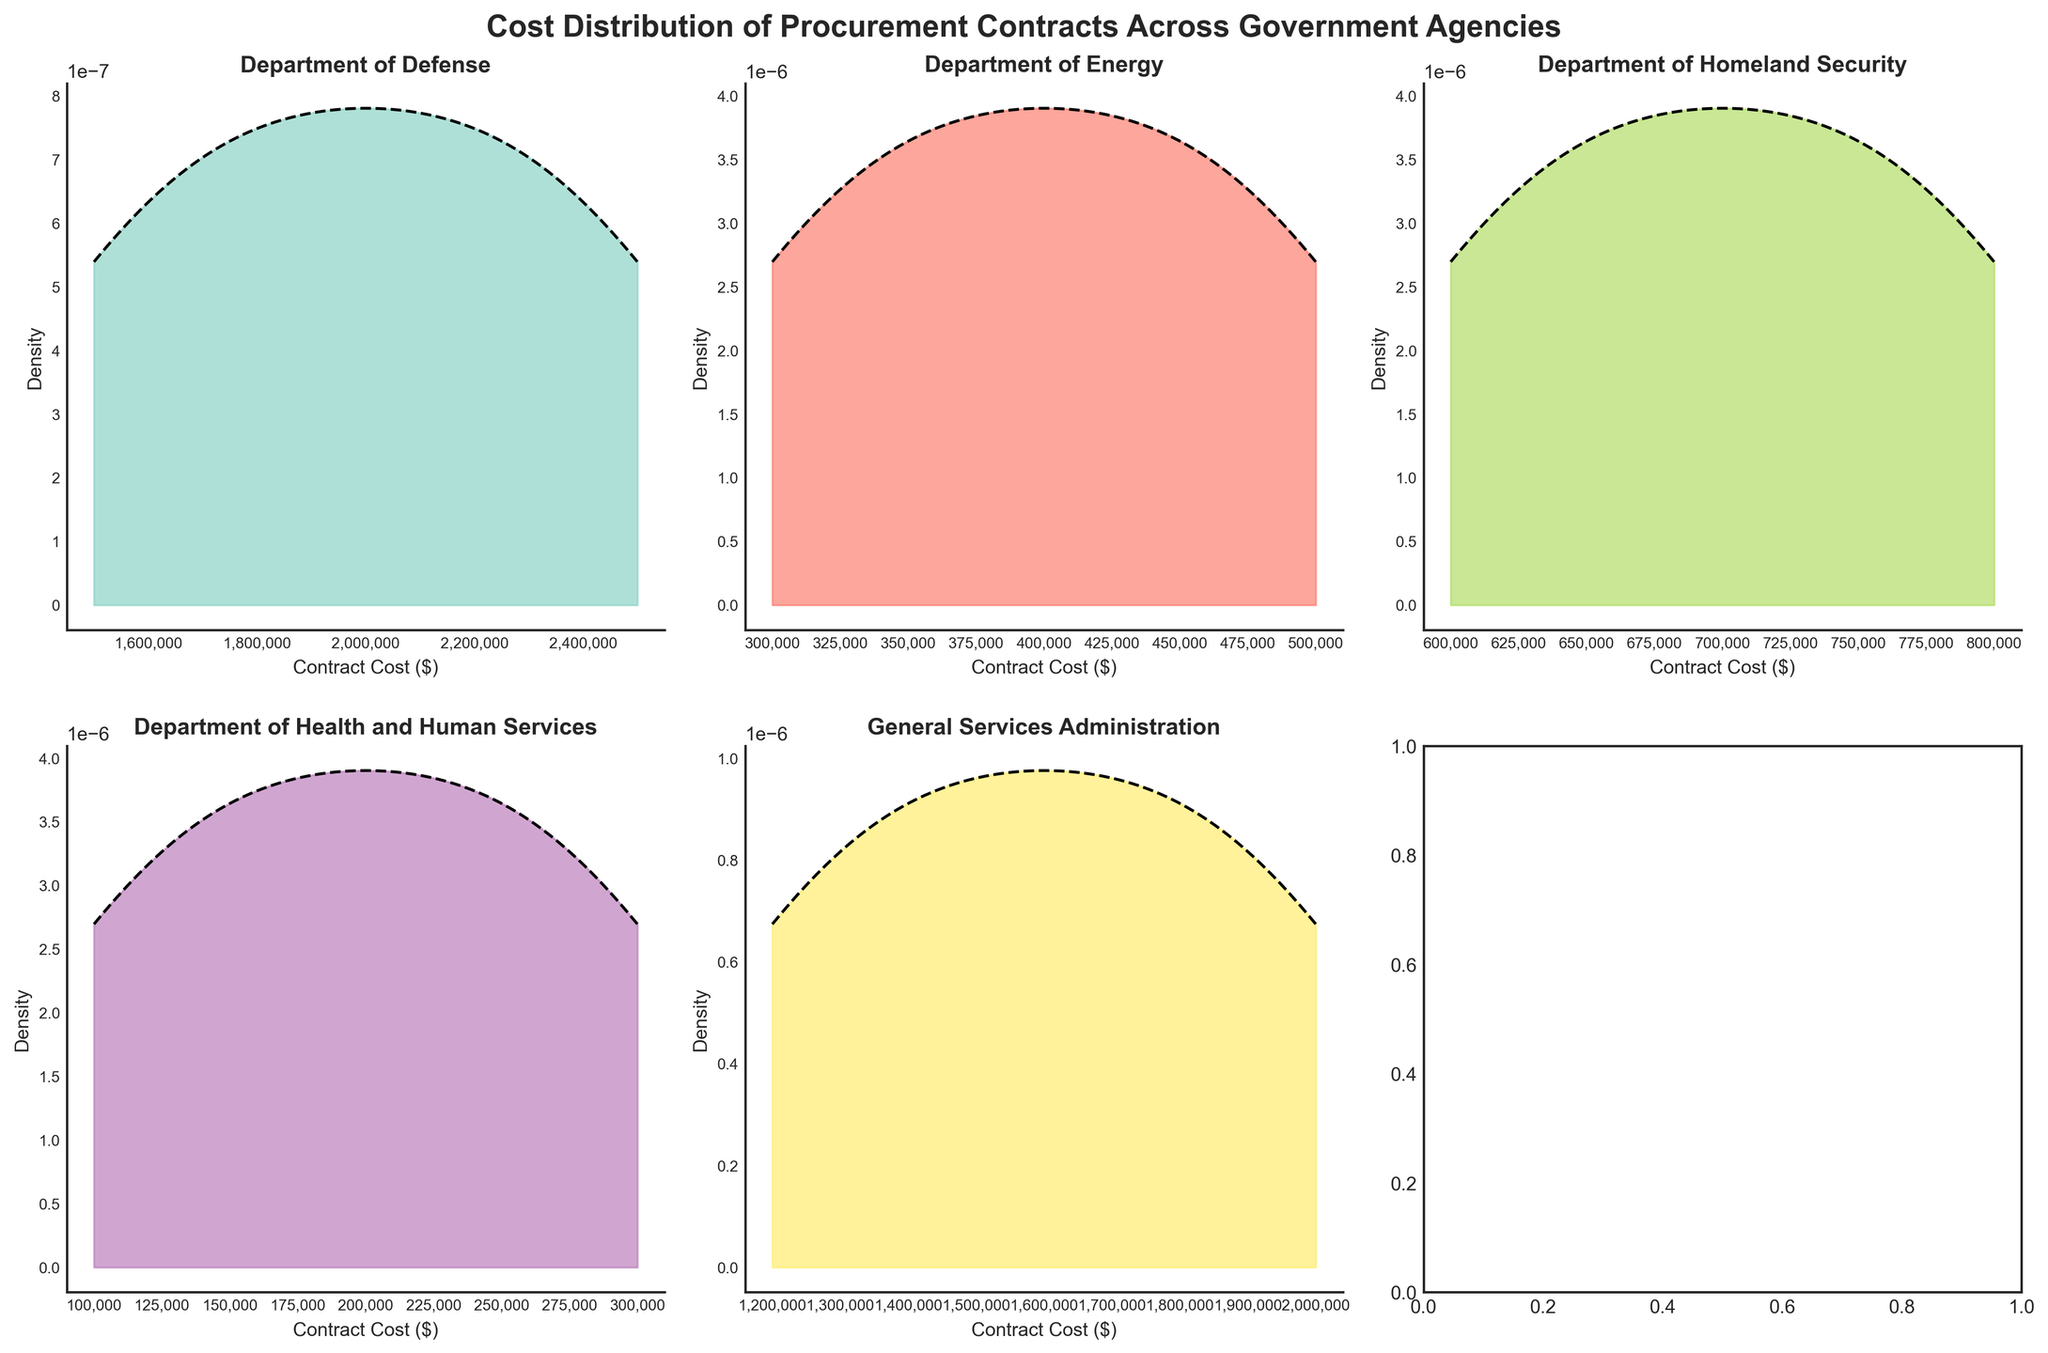Which government agency has the highest peak density for contract costs? To determine the agency with the highest peak density, look for the subplot where the density curve reaches the highest point.
Answer: Department of Defense What is the range of contract costs for the Department of Energy? The range can be identified by looking at the x-axis of the Department of Energy subplot and noting the minimum and maximum values.
Answer: $300,000 to $500,000 Which two agencies have the most overlapping distributions of contract costs? Overlapping distributions can be recognized where the density curves of two subplots appear similar in shape and range on the x-axis.
Answer: General Services Administration and Department of Defense Between the Department of Homeland Security and the Department of Health and Human Services, which agency's contracts are more spread out in terms of cost? A wider spread in contract costs will be indicated by a broader base of the density curve.
Answer: Department of Homeland Security Which agency has the least variability in contract costs? The agency with the least variability will have the narrowest and highest peak of the density curve, indicating tightly clustered contract costs.
Answer: Department of Energy Are the median contract costs higher for the Department of Defense or the General Services Administration? To estimate the median, which is the point where the density curve splits the area under it into equal halves, look at the center of the density curve for both agencies.
Answer: Department of Defense How many agencies have a density curve with multiple peaks? Look for subplots where the density curve has more than one peak, indicating a bimodal or multimodal distribution.
Answer: None Does any agency's contracts display a uniform distribution? A uniform distribution would be represented by a flat density curve without significant peaks or troughs.
Answer: No What might be the reason for differences in the shape of the density curves across different agencies? Consider potential factors such as the scale of operations, budget allocations, and nature of projects specific to each agency.
Answer: Varies by agency's scope and mission Which agency's density curve indicates that most of their contract costs are concentrated around a particular value? Look for the steepest peak in the density curve, suggesting that the costs are highly concentrated around a certain value.
Answer: Department of Health and Human Services 